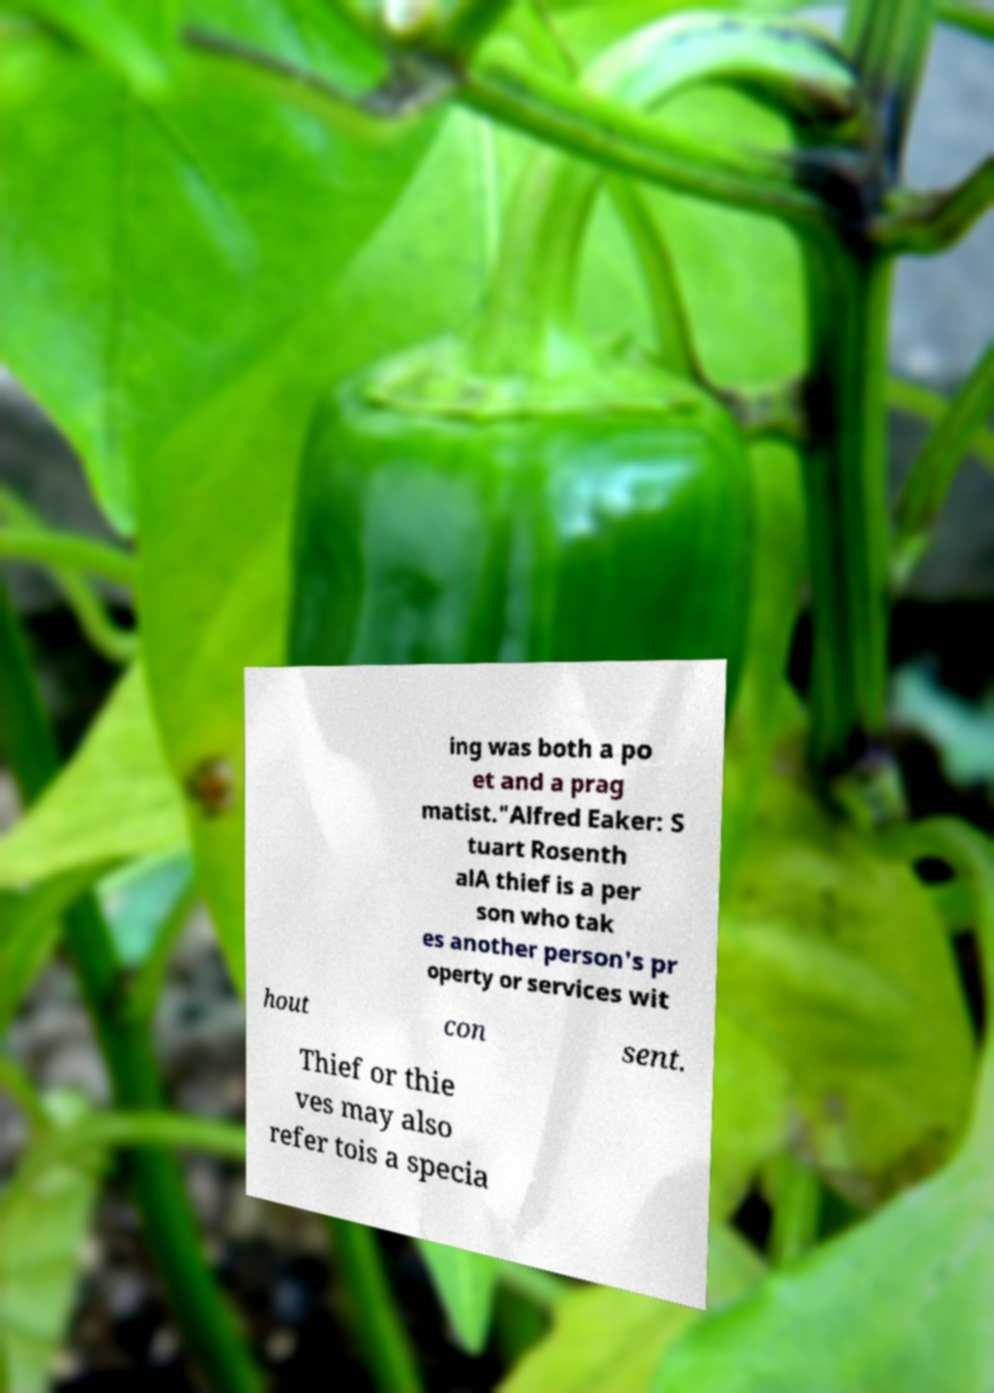Can you accurately transcribe the text from the provided image for me? ing was both a po et and a prag matist."Alfred Eaker: S tuart Rosenth alA thief is a per son who tak es another person's pr operty or services wit hout con sent. Thief or thie ves may also refer tois a specia 